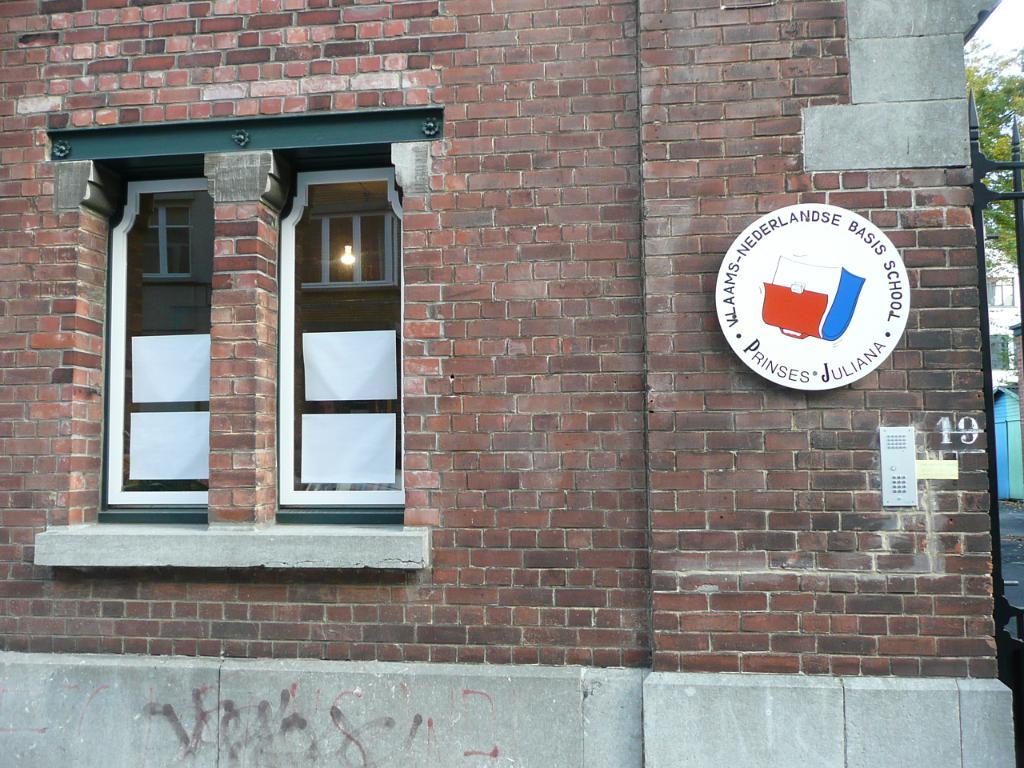What type of structure can be seen in the image? There is a wall in the image. What feature allows for natural light to enter the space? There is a window in the image. What is written or displayed on a board in the image? There is a board with text in the image. What can be seen in the sky in the image? The sky is visible in the image. What type of man-made structures are present in the image? There are buildings in the image. What type of natural vegetation is present in the image? There are trees in the image. How much does the scarf weigh in the image? There is no scarf present in the image, so its weight cannot be determined. Is the boat visible in the image? There is no boat present in the image. 